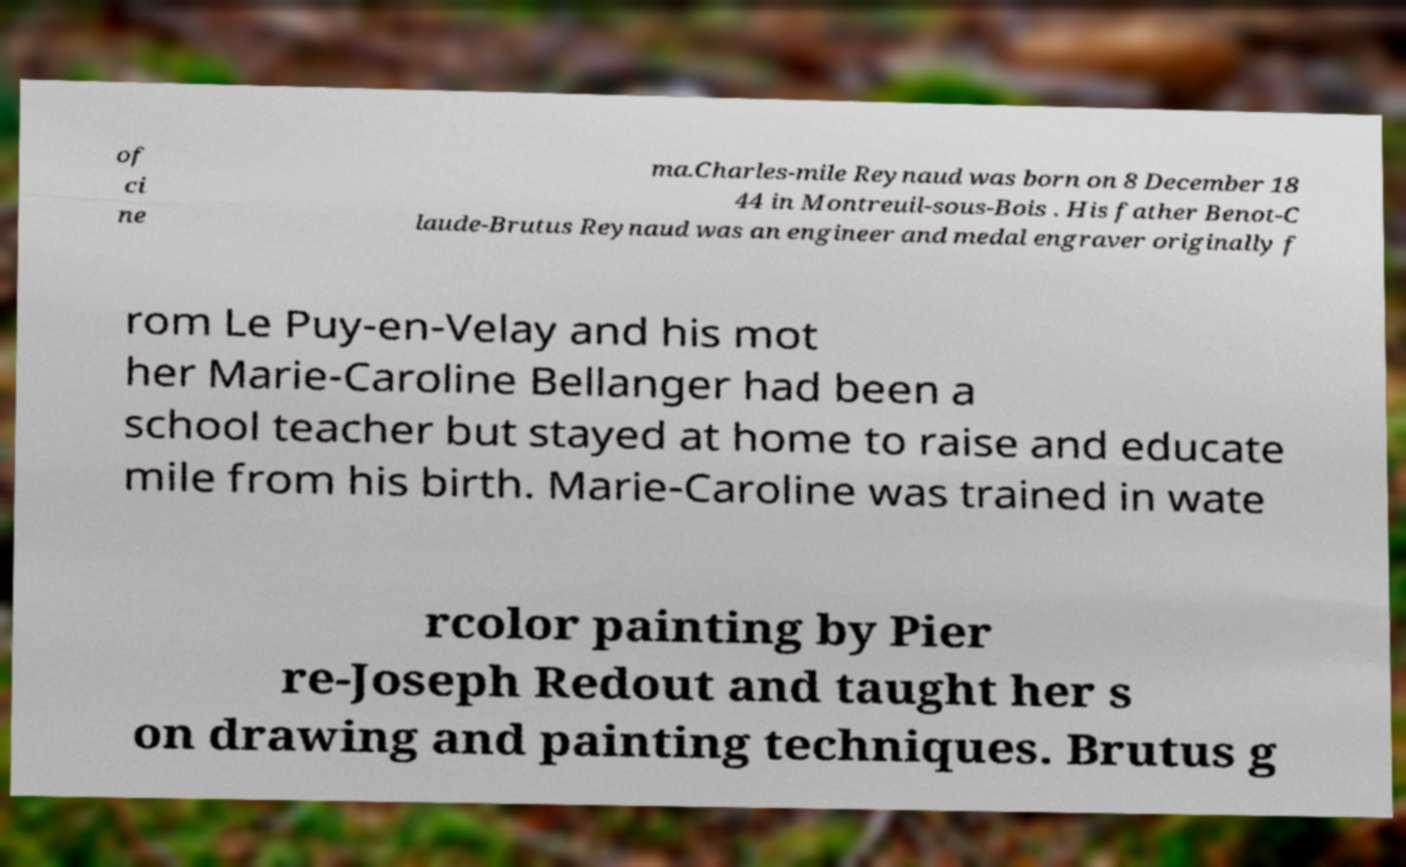For documentation purposes, I need the text within this image transcribed. Could you provide that? of ci ne ma.Charles-mile Reynaud was born on 8 December 18 44 in Montreuil-sous-Bois . His father Benot-C laude-Brutus Reynaud was an engineer and medal engraver originally f rom Le Puy-en-Velay and his mot her Marie-Caroline Bellanger had been a school teacher but stayed at home to raise and educate mile from his birth. Marie-Caroline was trained in wate rcolor painting by Pier re-Joseph Redout and taught her s on drawing and painting techniques. Brutus g 